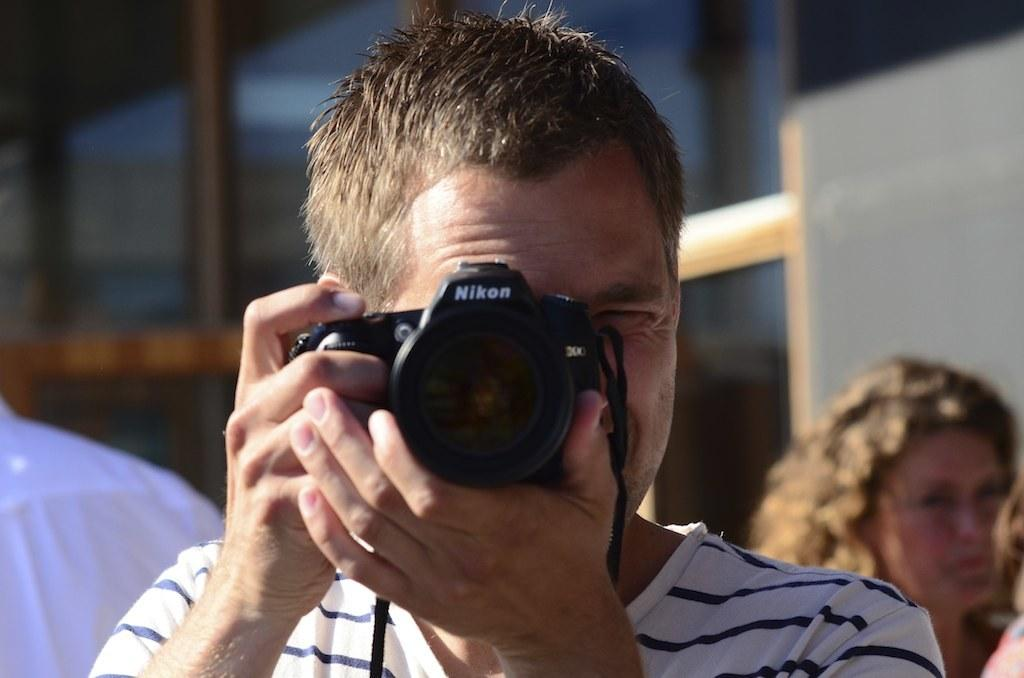Who is the main subject in the image? There is a man in the image. What is the man holding in the image? The man is holding a camera. Can you describe the background of the image? There are people visible in the background of the image. What type of steam can be seen coming from the man's camera in the image? There is no steam visible coming from the man's camera in the image. 